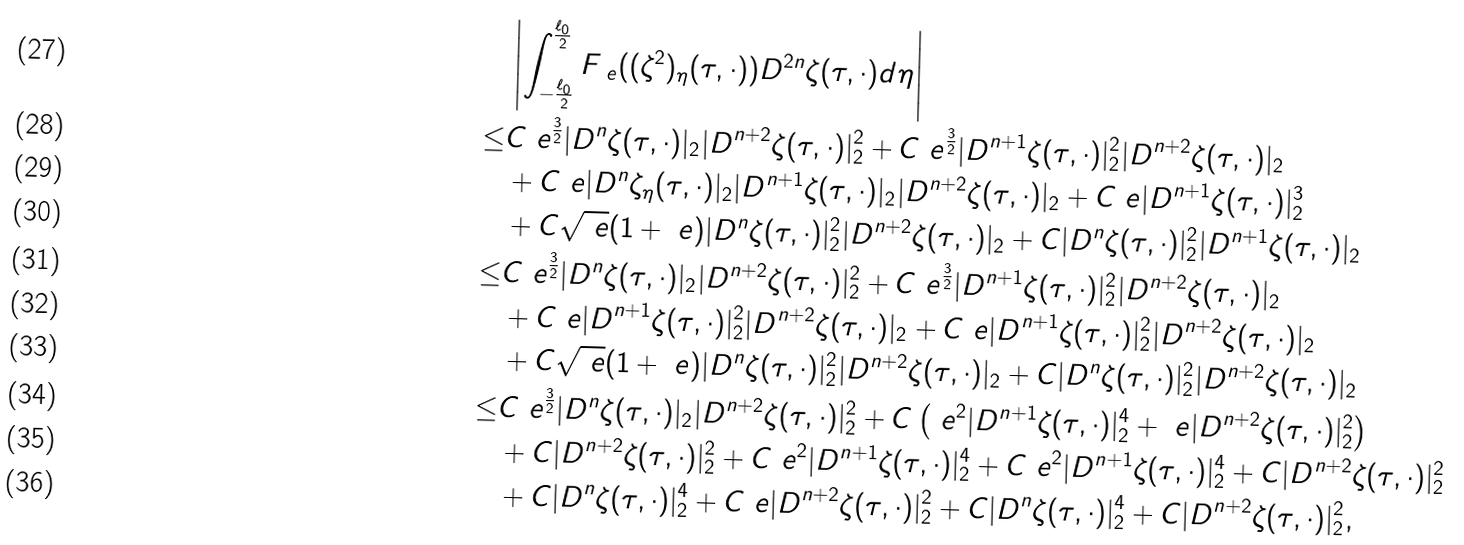<formula> <loc_0><loc_0><loc_500><loc_500>& \left | \int _ { - \frac { \ell _ { 0 } } { 2 } } ^ { \frac { \ell _ { 0 } } { 2 } } F _ { \ e } ( ( \zeta ^ { 2 } ) _ { \eta } ( \tau , \cdot ) ) D ^ { 2 n } \zeta ( \tau , \cdot ) d \eta \right | \\ \leq & C \ e ^ { \frac { 3 } { 2 } } | D ^ { n } \zeta ( \tau , \cdot ) | _ { 2 } | D ^ { n + 2 } \zeta ( \tau , \cdot ) | _ { 2 } ^ { 2 } + C \ e ^ { \frac { 3 } { 2 } } | D ^ { n + 1 } \zeta ( \tau , \cdot ) | _ { 2 } ^ { 2 } | D ^ { n + 2 } \zeta ( \tau , \cdot ) | _ { 2 } \\ & + C \ e | D ^ { n } \zeta _ { \eta } ( \tau , \cdot ) | _ { 2 } | D ^ { n + 1 } \zeta ( \tau , \cdot ) | _ { 2 } | D ^ { n + 2 } \zeta ( \tau , \cdot ) | _ { 2 } + C \ e | D ^ { n + 1 } \zeta ( \tau , \cdot ) | _ { 2 } ^ { 3 } \\ & + C \sqrt { \ e } ( 1 + \ e ) | D ^ { n } \zeta ( \tau , \cdot ) | _ { 2 } ^ { 2 } | D ^ { n + 2 } \zeta ( \tau , \cdot ) | _ { 2 } + C | D ^ { n } \zeta ( \tau , \cdot ) | _ { 2 } ^ { 2 } | D ^ { n + 1 } \zeta ( \tau , \cdot ) | _ { 2 } \\ \leq & C \ e ^ { \frac { 3 } { 2 } } | D ^ { n } \zeta ( \tau , \cdot ) | _ { 2 } | D ^ { n + 2 } \zeta ( \tau , \cdot ) | _ { 2 } ^ { 2 } + C \ e ^ { \frac { 3 } { 2 } } | D ^ { n + 1 } \zeta ( \tau , \cdot ) | _ { 2 } ^ { 2 } | D ^ { n + 2 } \zeta ( \tau , \cdot ) | _ { 2 } \\ & + C \ e | D ^ { n + 1 } \zeta ( \tau , \cdot ) | _ { 2 } ^ { 2 } | D ^ { n + 2 } \zeta ( \tau , \cdot ) | _ { 2 } + C \ e | D ^ { n + 1 } \zeta ( \tau , \cdot ) | _ { 2 } ^ { 2 } | D ^ { n + 2 } \zeta ( \tau , \cdot ) | _ { 2 } \\ & + C \sqrt { \ e } ( 1 + \ e ) | D ^ { n } \zeta ( \tau , \cdot ) | _ { 2 } ^ { 2 } | D ^ { n + 2 } \zeta ( \tau , \cdot ) | _ { 2 } + C | D ^ { n } \zeta ( \tau , \cdot ) | _ { 2 } ^ { 2 } | D ^ { n + 2 } \zeta ( \tau , \cdot ) | _ { 2 } \\ \leq & C \ e ^ { \frac { 3 } { 2 } } | D ^ { n } \zeta ( \tau , \cdot ) | _ { 2 } | D ^ { n + 2 } \zeta ( \tau , \cdot ) | _ { 2 } ^ { 2 } + C \left ( \ e ^ { 2 } | D ^ { n + 1 } \zeta ( \tau , \cdot ) | _ { 2 } ^ { 4 } + \ e | D ^ { n + 2 } \zeta ( \tau , \cdot ) | _ { 2 } ^ { 2 } \right ) \\ & + C | D ^ { n + 2 } \zeta ( \tau , \cdot ) | _ { 2 } ^ { 2 } + C \ e ^ { 2 } | D ^ { n + 1 } \zeta ( \tau , \cdot ) | _ { 2 } ^ { 4 } + C \ e ^ { 2 } | D ^ { n + 1 } \zeta ( \tau , \cdot ) | _ { 2 } ^ { 4 } + C | D ^ { n + 2 } \zeta ( \tau , \cdot ) | _ { 2 } ^ { 2 } \\ & + C | D ^ { n } \zeta ( \tau , \cdot ) | _ { 2 } ^ { 4 } + C \ e | D ^ { n + 2 } \zeta ( \tau , \cdot ) | _ { 2 } ^ { 2 } + C | D ^ { n } \zeta ( \tau , \cdot ) | _ { 2 } ^ { 4 } + C | D ^ { n + 2 } \zeta ( \tau , \cdot ) | _ { 2 } ^ { 2 } ,</formula> 